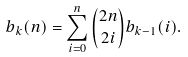<formula> <loc_0><loc_0><loc_500><loc_500>b _ { k } ( n ) = \sum _ { i = 0 } ^ { n } \binom { 2 n } { 2 i } b _ { k - 1 } ( i ) .</formula> 